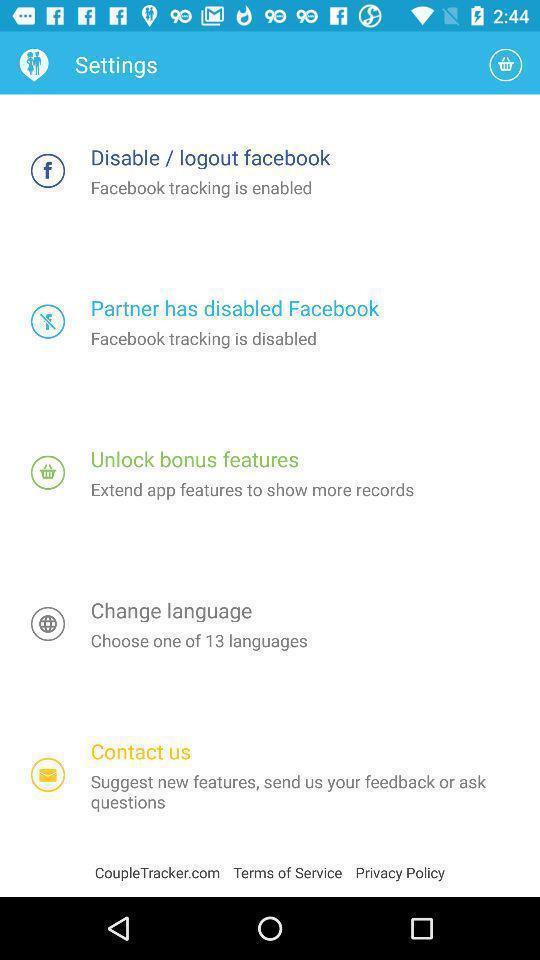Please provide a description for this image. Screen page of a settings. 